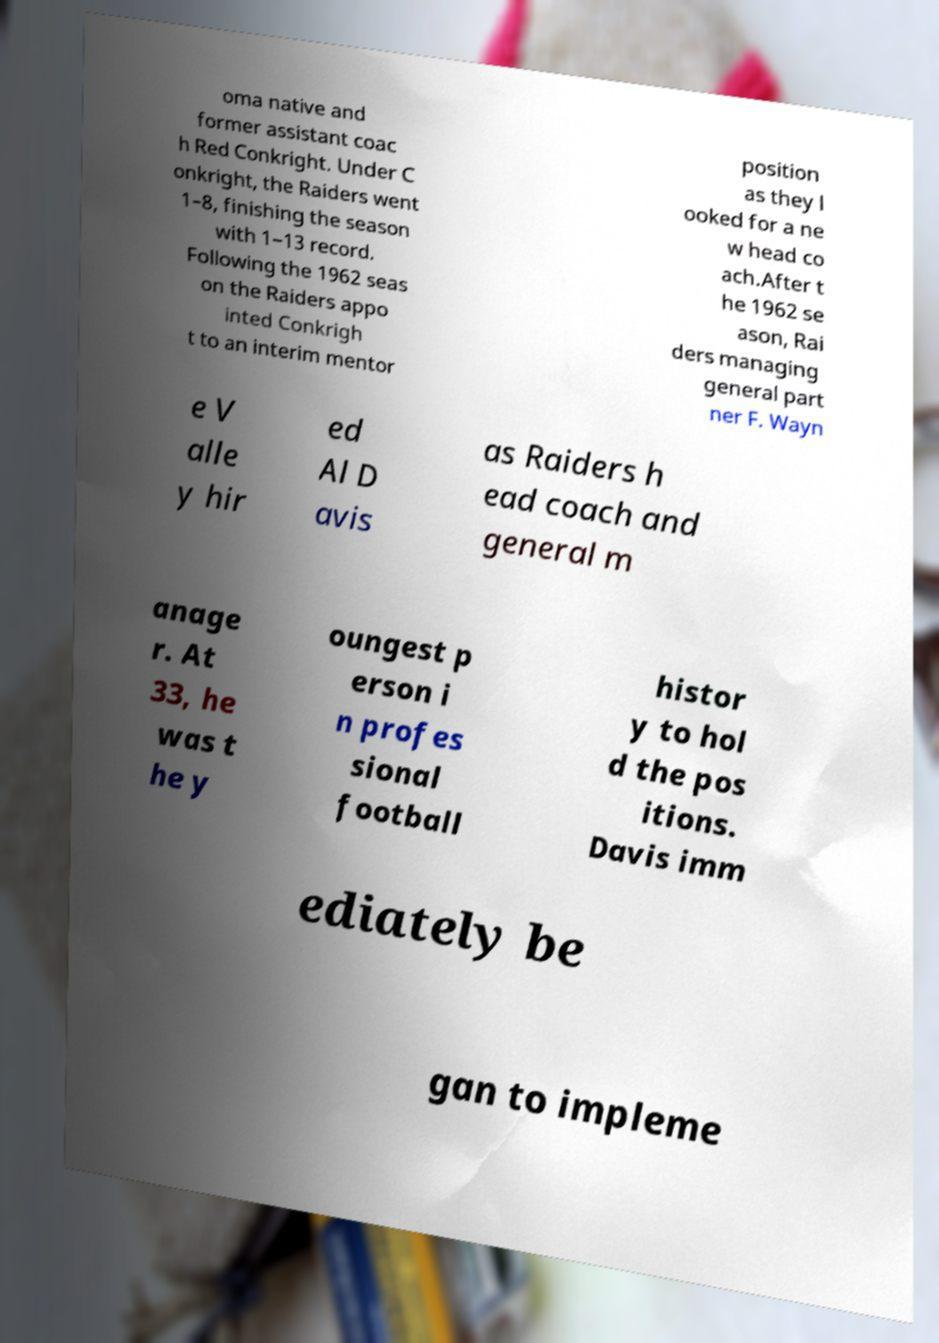Please read and relay the text visible in this image. What does it say? oma native and former assistant coac h Red Conkright. Under C onkright, the Raiders went 1–8, finishing the season with 1–13 record. Following the 1962 seas on the Raiders appo inted Conkrigh t to an interim mentor position as they l ooked for a ne w head co ach.After t he 1962 se ason, Rai ders managing general part ner F. Wayn e V alle y hir ed Al D avis as Raiders h ead coach and general m anage r. At 33, he was t he y oungest p erson i n profes sional football histor y to hol d the pos itions. Davis imm ediately be gan to impleme 